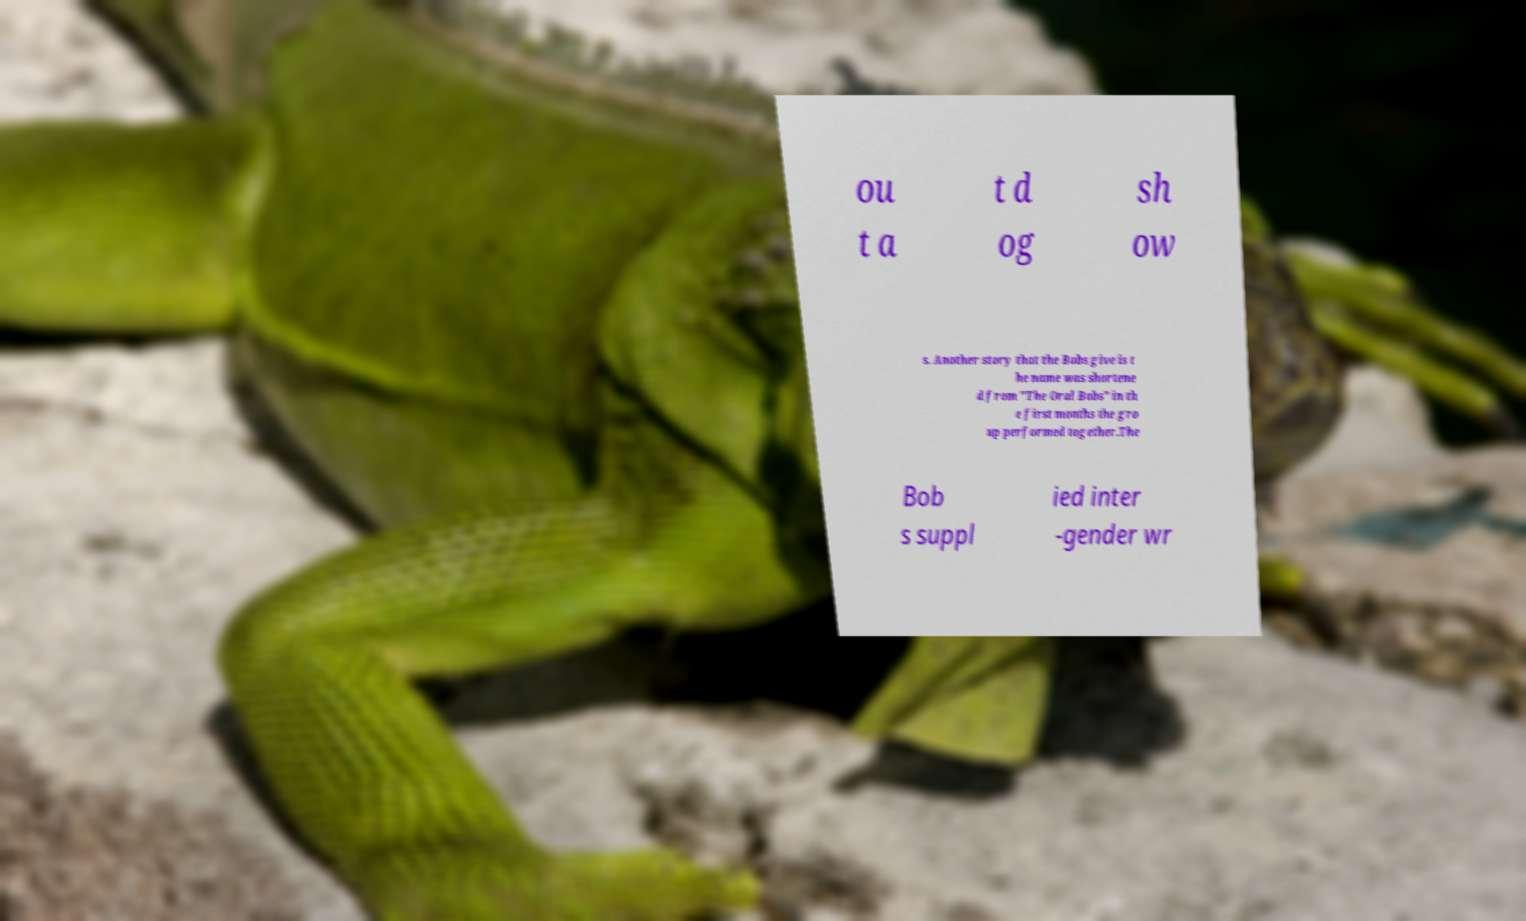I need the written content from this picture converted into text. Can you do that? ou t a t d og sh ow s. Another story that the Bobs give is t he name was shortene d from "The Oral Bobs" in th e first months the gro up performed together.The Bob s suppl ied inter -gender wr 